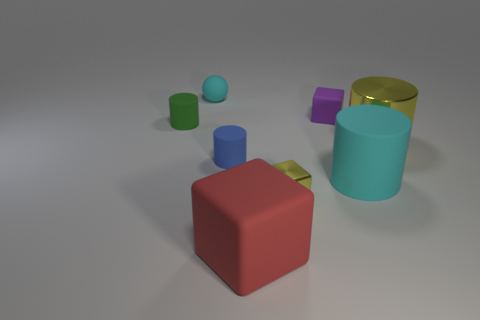How many small red spheres are there?
Your answer should be compact. 0. How big is the yellow thing to the left of the metal thing that is on the right side of the cyan matte object in front of the shiny cylinder?
Your answer should be compact. Small. Does the rubber ball have the same color as the big rubber cylinder?
Your answer should be very brief. Yes. What number of green rubber objects are on the left side of the cyan matte sphere?
Offer a very short reply. 1. Are there the same number of cyan spheres in front of the green cylinder and tiny cyan matte blocks?
Make the answer very short. Yes. How many things are either small purple objects or small blue matte cylinders?
Provide a succinct answer. 2. Is there any other thing that has the same shape as the tiny cyan rubber thing?
Provide a succinct answer. No. There is a large matte object that is right of the matte block that is in front of the tiny metal object; what shape is it?
Your response must be concise. Cylinder. What is the shape of the large cyan thing that is the same material as the cyan sphere?
Make the answer very short. Cylinder. What is the size of the cyan object that is to the left of the big cyan matte cylinder that is on the left side of the large yellow cylinder?
Provide a short and direct response. Small. 